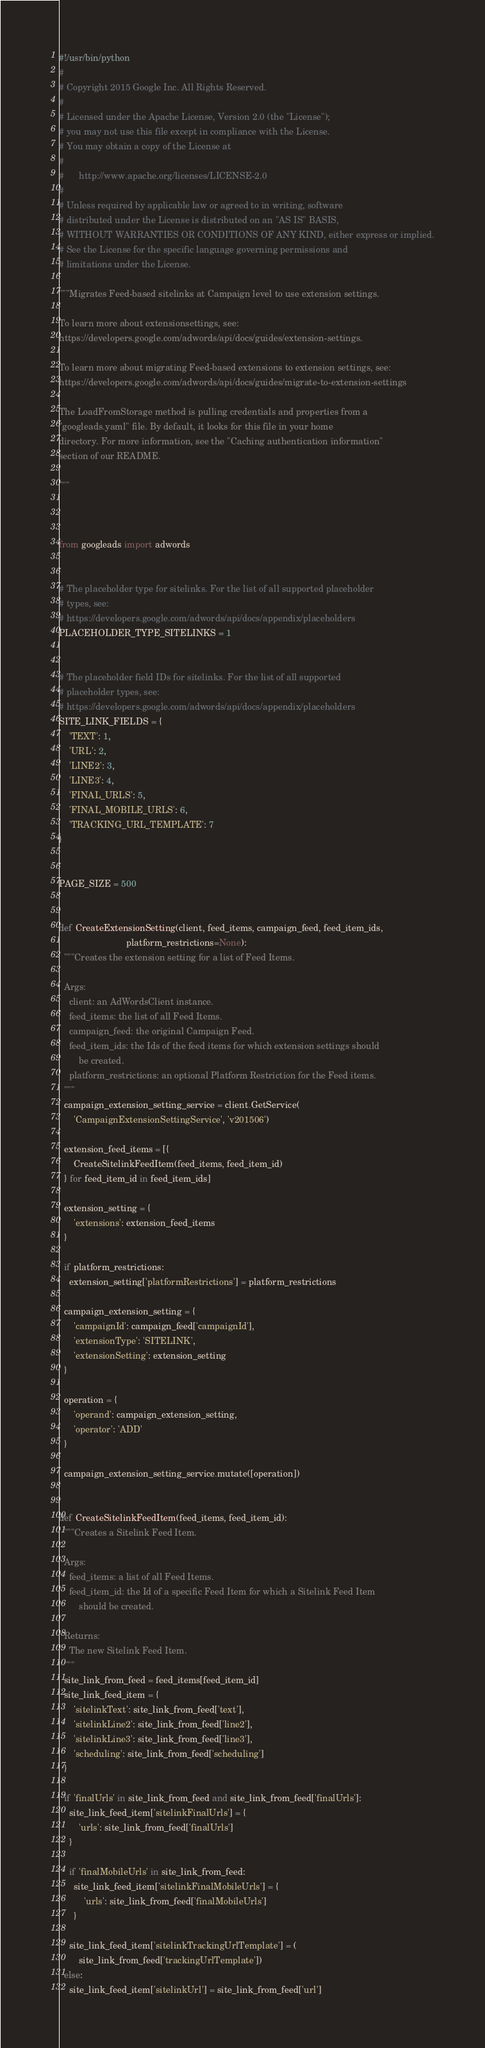<code> <loc_0><loc_0><loc_500><loc_500><_Python_>#!/usr/bin/python
#
# Copyright 2015 Google Inc. All Rights Reserved.
#
# Licensed under the Apache License, Version 2.0 (the "License");
# you may not use this file except in compliance with the License.
# You may obtain a copy of the License at
#
#      http://www.apache.org/licenses/LICENSE-2.0
#
# Unless required by applicable law or agreed to in writing, software
# distributed under the License is distributed on an "AS IS" BASIS,
# WITHOUT WARRANTIES OR CONDITIONS OF ANY KIND, either express or implied.
# See the License for the specific language governing permissions and
# limitations under the License.

"""Migrates Feed-based sitelinks at Campaign level to use extension settings.

To learn more about extensionsettings, see:
https://developers.google.com/adwords/api/docs/guides/extension-settings.

To learn more about migrating Feed-based extensions to extension settings, see:
https://developers.google.com/adwords/api/docs/guides/migrate-to-extension-settings

The LoadFromStorage method is pulling credentials and properties from a
"googleads.yaml" file. By default, it looks for this file in your home
directory. For more information, see the "Caching authentication information"
section of our README.

"""



from googleads import adwords


# The placeholder type for sitelinks. For the list of all supported placeholder
# types, see:
# https://developers.google.com/adwords/api/docs/appendix/placeholders
PLACEHOLDER_TYPE_SITELINKS = 1


# The placeholder field IDs for sitelinks. For the list of all supported
# placeholder types, see:
# https://developers.google.com/adwords/api/docs/appendix/placeholders
SITE_LINK_FIELDS = {
    'TEXT': 1,
    'URL': 2,
    'LINE2': 3,
    'LINE3': 4,
    'FINAL_URLS': 5,
    'FINAL_MOBILE_URLS': 6,
    'TRACKING_URL_TEMPLATE': 7
}


PAGE_SIZE = 500


def CreateExtensionSetting(client, feed_items, campaign_feed, feed_item_ids,
                           platform_restrictions=None):
  """Creates the extension setting for a list of Feed Items.

  Args:
    client: an AdWordsClient instance.
    feed_items: the list of all Feed Items.
    campaign_feed: the original Campaign Feed.
    feed_item_ids: the Ids of the feed items for which extension settings should
        be created.
    platform_restrictions: an optional Platform Restriction for the Feed items.
  """
  campaign_extension_setting_service = client.GetService(
      'CampaignExtensionSettingService', 'v201506')

  extension_feed_items = [{
      CreateSitelinkFeedItem(feed_items, feed_item_id)
  } for feed_item_id in feed_item_ids]

  extension_setting = {
      'extensions': extension_feed_items
  }

  if platform_restrictions:
    extension_setting['platformRestrictions'] = platform_restrictions

  campaign_extension_setting = {
      'campaignId': campaign_feed['campaignId'],
      'extensionType': 'SITELINK',
      'extensionSetting': extension_setting
  }

  operation = {
      'operand': campaign_extension_setting,
      'operator': 'ADD'
  }

  campaign_extension_setting_service.mutate([operation])


def CreateSitelinkFeedItem(feed_items, feed_item_id):
  """Creates a Sitelink Feed Item.

  Args:
    feed_items: a list of all Feed Items.
    feed_item_id: the Id of a specific Feed Item for which a Sitelink Feed Item
        should be created.

  Returns:
    The new Sitelink Feed Item.
  """
  site_link_from_feed = feed_items[feed_item_id]
  site_link_feed_item = {
      'sitelinkText': site_link_from_feed['text'],
      'sitelinkLine2': site_link_from_feed['line2'],
      'sitelinkLine3': site_link_from_feed['line3'],
      'scheduling': site_link_from_feed['scheduling']
  }

  if 'finalUrls' in site_link_from_feed and site_link_from_feed['finalUrls']:
    site_link_feed_item['sitelinkFinalUrls'] = {
        'urls': site_link_from_feed['finalUrls']
    }

    if 'finalMobileUrls' in site_link_from_feed:
      site_link_feed_item['sitelinkFinalMobileUrls'] = {
          'urls': site_link_from_feed['finalMobileUrls']
      }

    site_link_feed_item['sitelinkTrackingUrlTemplate'] = (
        site_link_from_feed['trackingUrlTemplate'])
  else:
    site_link_feed_item['sitelinkUrl'] = site_link_from_feed['url']
</code> 